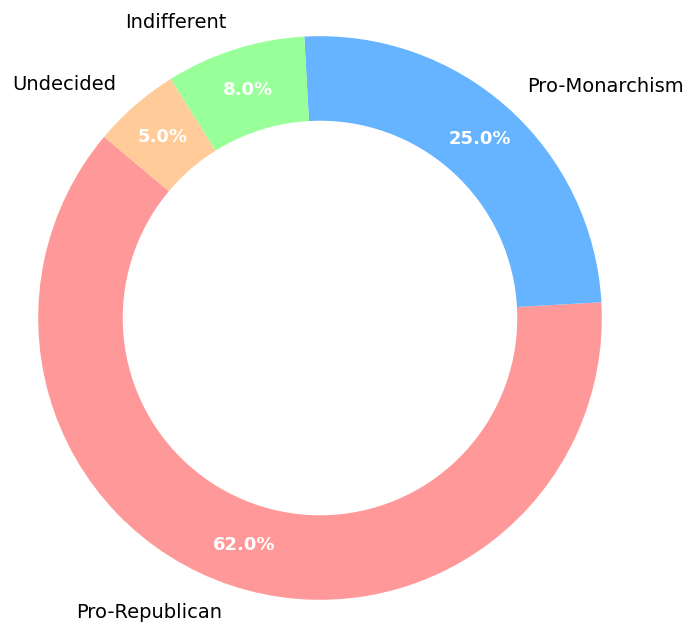What percentage of Serbian citizens are pro-republican? To find the percentage of Serbian citizens who are pro-republican, we directly refer to the segment labeled 'Pro-Republican' in the pie chart.
Answer: 62% What is the combined percentage of people who are either indifferent or undecided on the matter? Add the percentage of those who are 'Indifferent' (8%) and 'Undecided' (5%). The sum is 8 + 5, which equals 13%.
Answer: 13% How much more popular is republicanism compared to monarchism? Subtract the percentage of people who are 'Pro-Monarchism' (25%) from the percentage of those who are 'Pro-Republican' (62%). The difference is 62 - 25, which equals 37%.
Answer: 37% Which category represents the smallest percentage? By examining the pie chart, we determine which segment is the smallest. The 'Undecided' category, showing 5%, is the smallest.
Answer: Undecided If the total number of respondents was 1,000, how many people were indifferent to the matter? Use the percentage of 'Indifferent' (8%) and apply it to 1,000 respondents. Calculate by multiplying (8/100) * 1,000, which equals 80.
Answer: 80 Which color represents the pro-republican segment in the pie chart? Observe the visual attributes in the pie chart, noting the color associated with the 'Pro-Republican' label. It is represented by red.
Answer: Red What is the total percentage of people who have a definite stance (either pro-republican or pro-monarchism)? Add the percentages of people who are 'Pro-Republican' (62%) and 'Pro-Monarchism' (25%). The sum is 62 + 25, which equals 87%.
Answer: 87% Which category has more respondents, indifferent or undecided? Compare the percentages of the 'Indifferent' (8%) and 'Undecided' (5%) categories. Since 8% is greater than 5%, the 'Indifferent' category has more respondents.
Answer: Indifferent What is the ratio of pro-republican to pro-monarchism respondents? Divide the percentage of 'Pro-Republican' (62%) by the percentage of 'Pro-Monarchism' (25%). This results in a ratio of 62/25, which simplifies to approximately 2.48.
Answer: 2.48 If you were to combine the percentages of indifferent and undecided respondents, would they form a larger segment than pro-monarchism? Compare the combined percentage of 'Indifferent' (8%) and 'Undecided' (5%) which totals 13%, against 'Pro-Monarchism' (25%). Since 13% is less than 25%, the combined segment is smaller.
Answer: No 